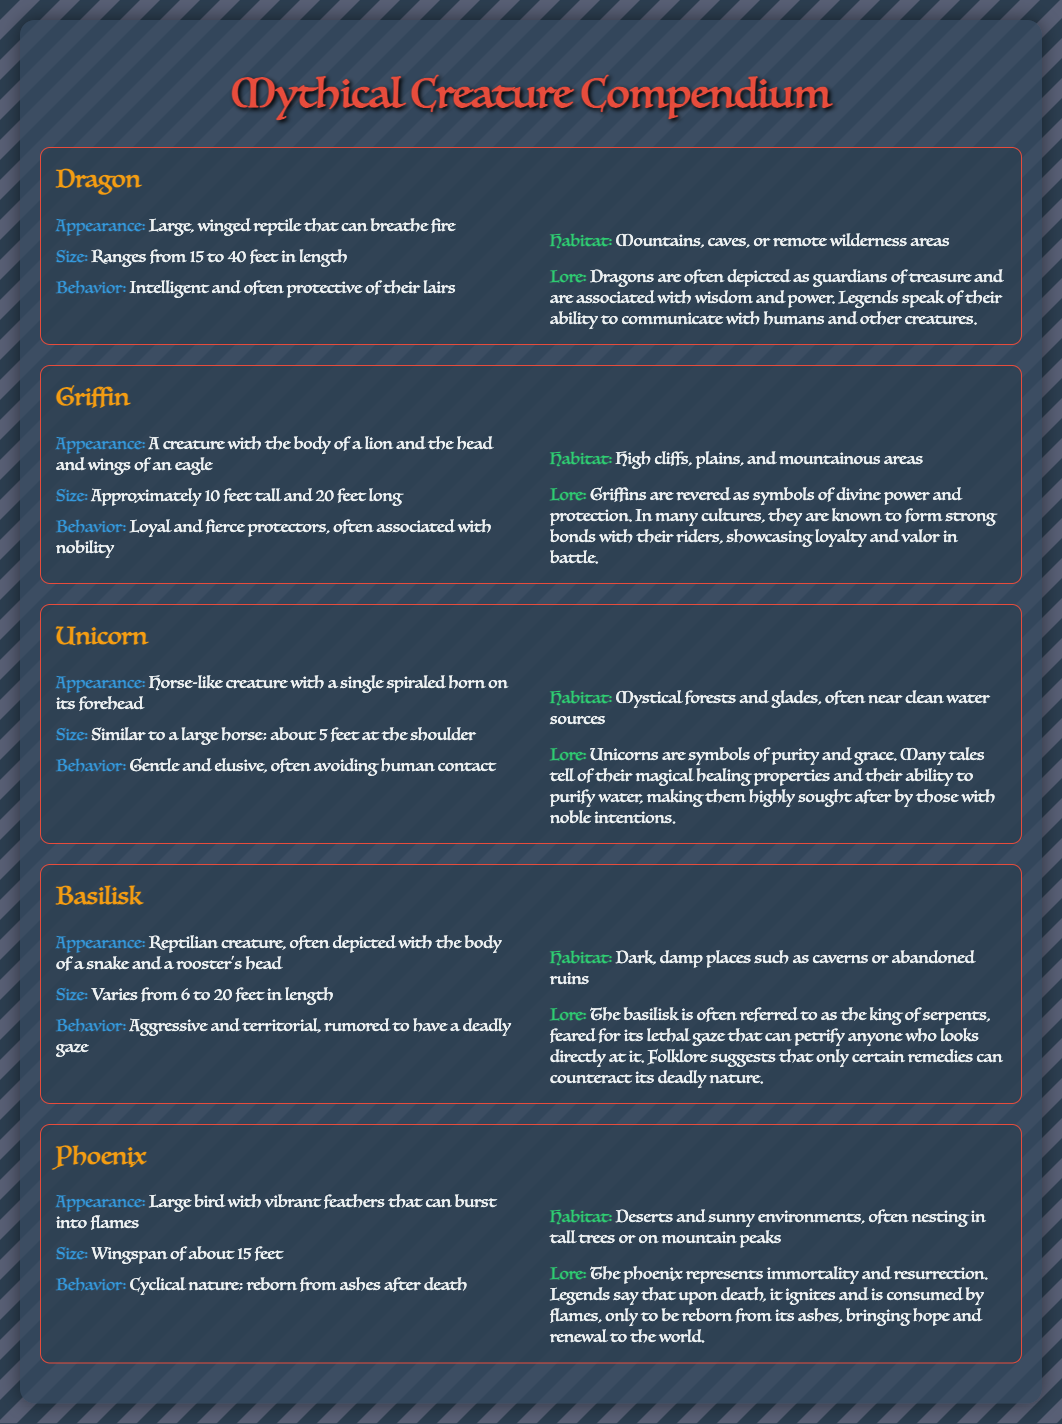What is the size range of a Dragon? The size range of a Dragon is mentioned as being between 15 to 40 feet in length.
Answer: 15 to 40 feet What kind of habitats do Griffins prefer? The document states that Griffins inhabit high cliffs, plains, and mountainous areas.
Answer: High cliffs, plains, mountainous areas What behavior is commonly associated with Unicorns? The document describes Unicorns as gentle and elusive, often avoiding human contact.
Answer: Gentle and elusive What is the appearance of a Basilisk? The Basilisk is depicted as a reptilian creature with the body of a snake and a rooster's head.
Answer: Body of a snake and a rooster's head How does a Phoenix represent immortality? The lore explains that a Phoenix is reborn from ashes after death, symbolizing immortality and resurrection.
Answer: Reborn from ashes What do Dragons guard? According to the lore, Dragons are often depicted as guardians of treasure.
Answer: Guardians of treasure What is a key characteristic of Griffin behavior? The document mentions that Griffins are loyal and fierce protectors.
Answer: Loyal and fierce protectors Where do Unicorns typically live? Unicorns typically inhabit mystical forests and glades, often near clean water sources.
Answer: Mystical forests and glades What is the deadly capability of a Basilisk? The Basilisk is rumored to have a deadly gaze that can petrify anyone who looks directly at it.
Answer: Deadly gaze 